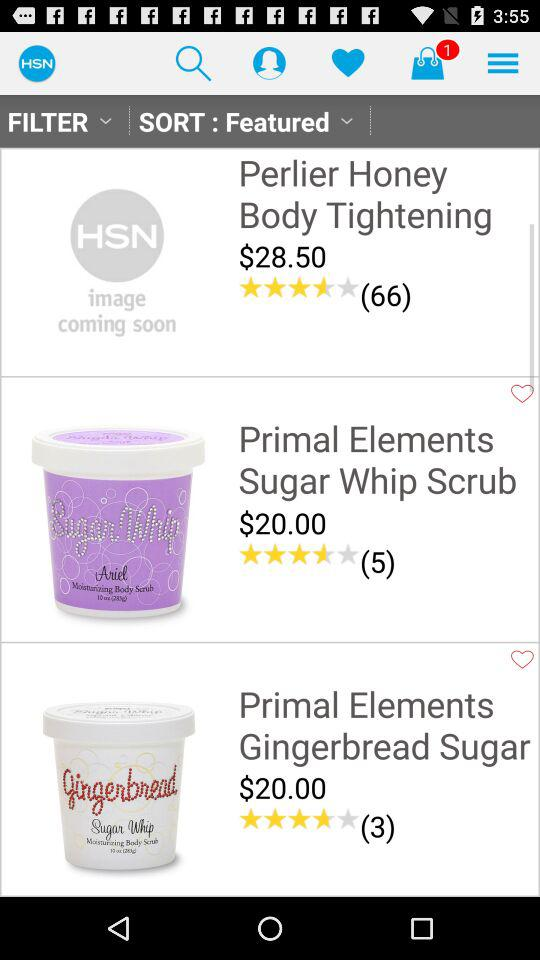How many products are there in total?
Answer the question using a single word or phrase. 3 